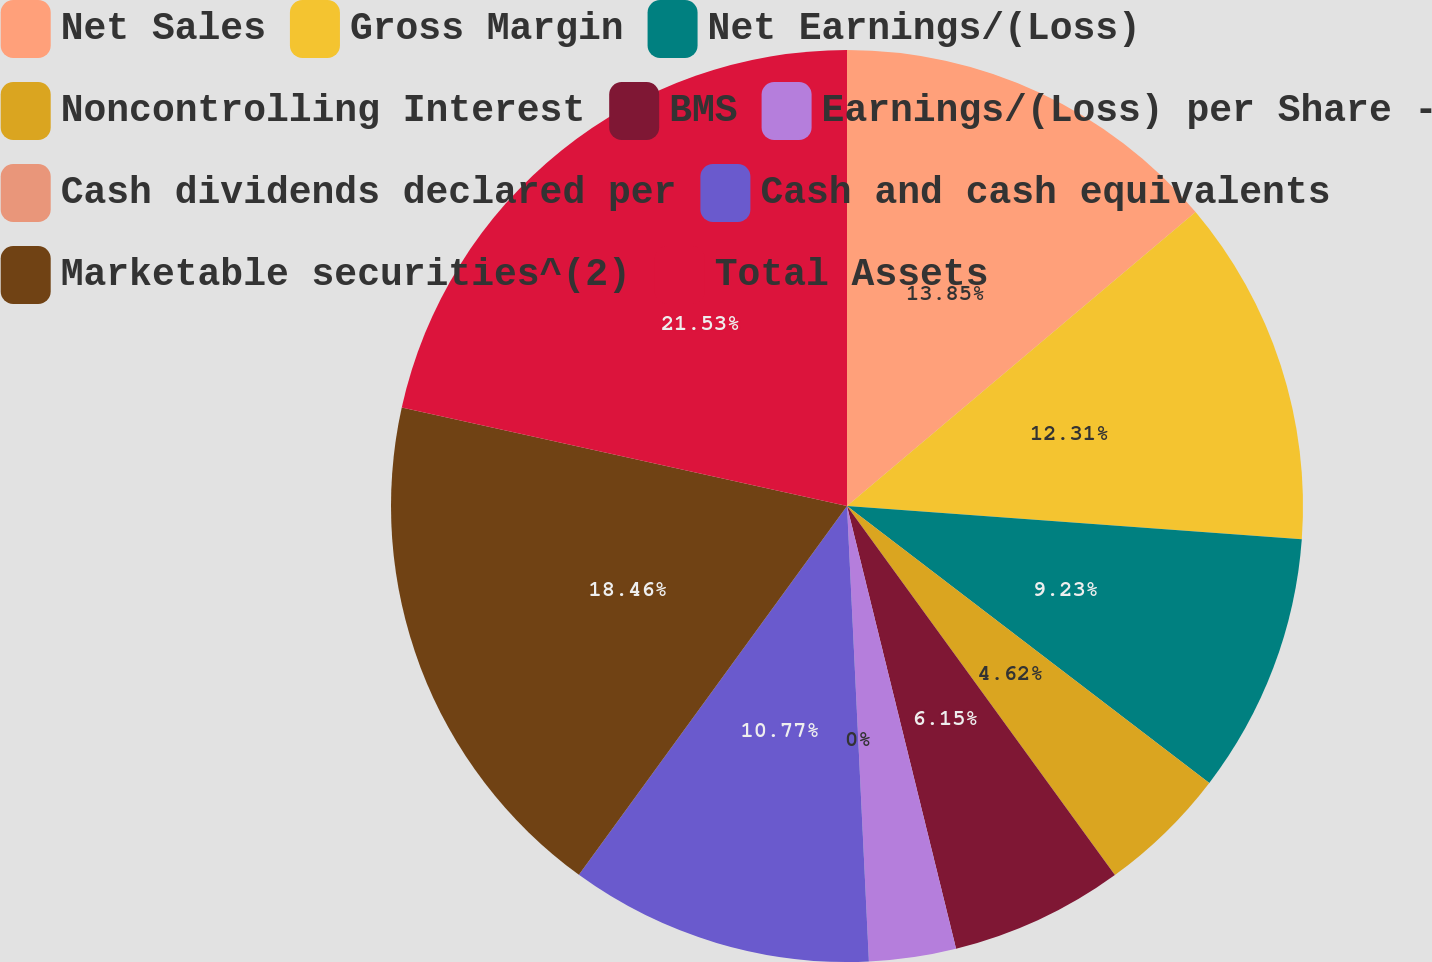Convert chart to OTSL. <chart><loc_0><loc_0><loc_500><loc_500><pie_chart><fcel>Net Sales<fcel>Gross Margin<fcel>Net Earnings/(Loss)<fcel>Noncontrolling Interest<fcel>BMS<fcel>Earnings/(Loss) per Share -<fcel>Cash dividends declared per<fcel>Cash and cash equivalents<fcel>Marketable securities^(2)<fcel>Total Assets<nl><fcel>13.85%<fcel>12.31%<fcel>9.23%<fcel>4.62%<fcel>6.15%<fcel>3.08%<fcel>0.0%<fcel>10.77%<fcel>18.46%<fcel>21.54%<nl></chart> 